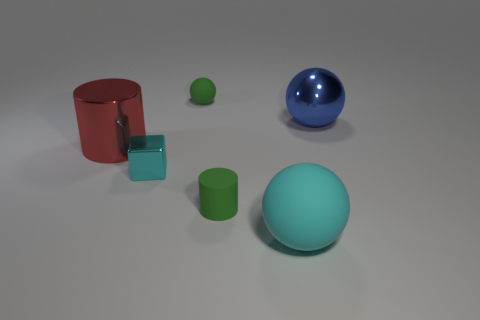Imagine these objects are used to explain a concept to children, what might that be? These objects could be a fantastic visual aid for teaching children about geometry and spatial relationships. The various shapes, like the spheres, cylinder, and cube, could help introduce basic geometric forms. Their differing sizes can illustrate concepts of big and small, while their color differences can be used to engage children in learning about sorting and categorization. Furthermore, the arrangement of these objects might be used to explain positioning with words like 'in front of', 'behind', 'left', and 'right', establishing a basic understanding of spatial awareness. 